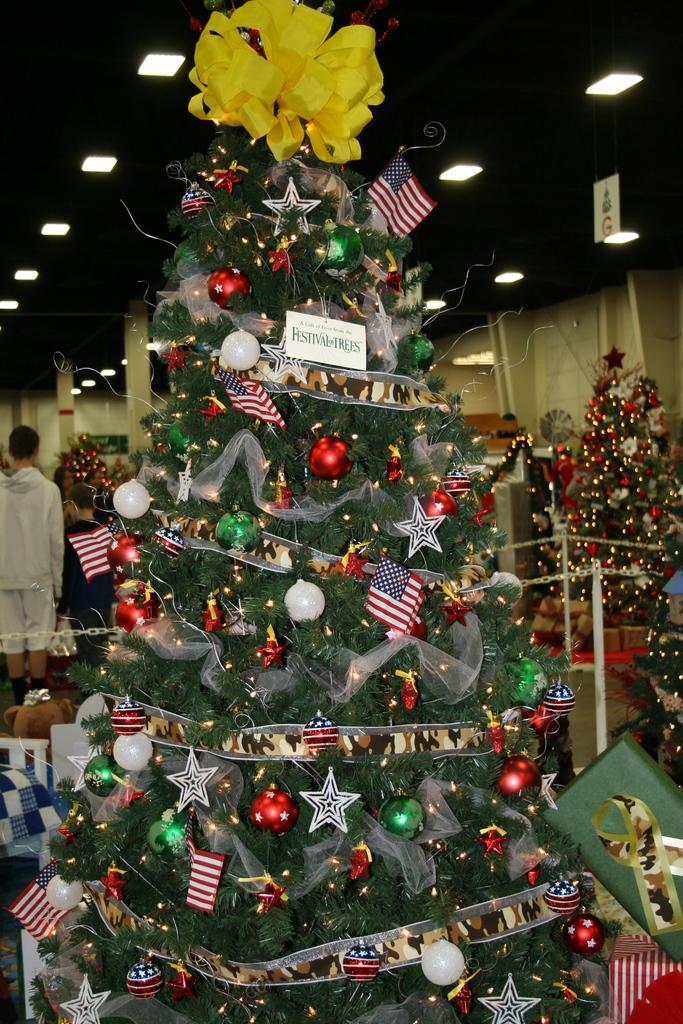Please provide a concise description of this image. In this picture I can see there is a Christmas tree, it is decorated with lights, ribbons, bells and flags. There are many more Christmas trees and there are few gifts placed on the floor. There is a boy and a man standing and there are lights attached to the ceiling. 